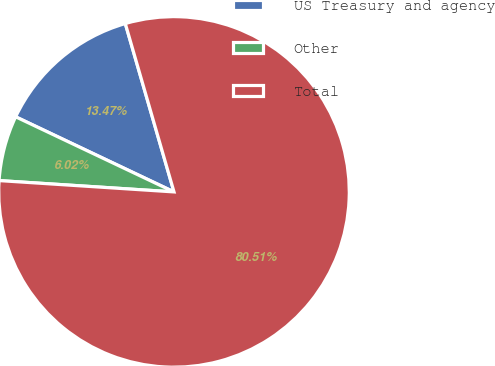<chart> <loc_0><loc_0><loc_500><loc_500><pie_chart><fcel>US Treasury and agency<fcel>Other<fcel>Total<nl><fcel>13.47%<fcel>6.02%<fcel>80.52%<nl></chart> 